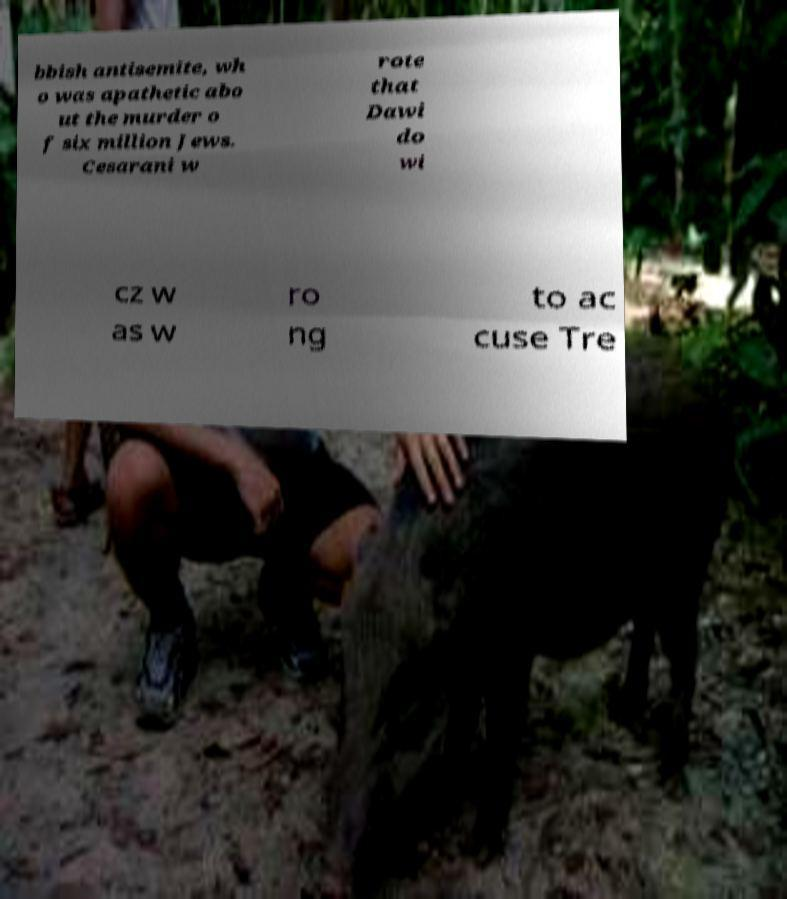Please read and relay the text visible in this image. What does it say? bbish antisemite, wh o was apathetic abo ut the murder o f six million Jews. Cesarani w rote that Dawi do wi cz w as w ro ng to ac cuse Tre 